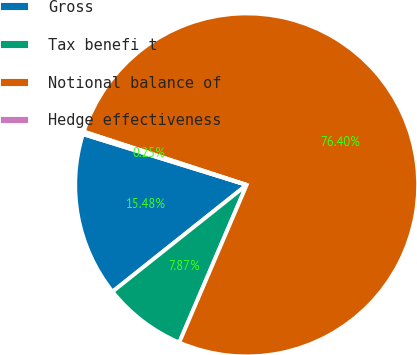Convert chart to OTSL. <chart><loc_0><loc_0><loc_500><loc_500><pie_chart><fcel>Gross<fcel>Tax benefi t<fcel>Notional balance of<fcel>Hedge effectiveness<nl><fcel>15.48%<fcel>7.87%<fcel>76.4%<fcel>0.25%<nl></chart> 